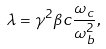Convert formula to latex. <formula><loc_0><loc_0><loc_500><loc_500>\lambda = \gamma ^ { 2 } \beta c \frac { \omega _ { c } } { \omega _ { b } ^ { 2 } } ,</formula> 